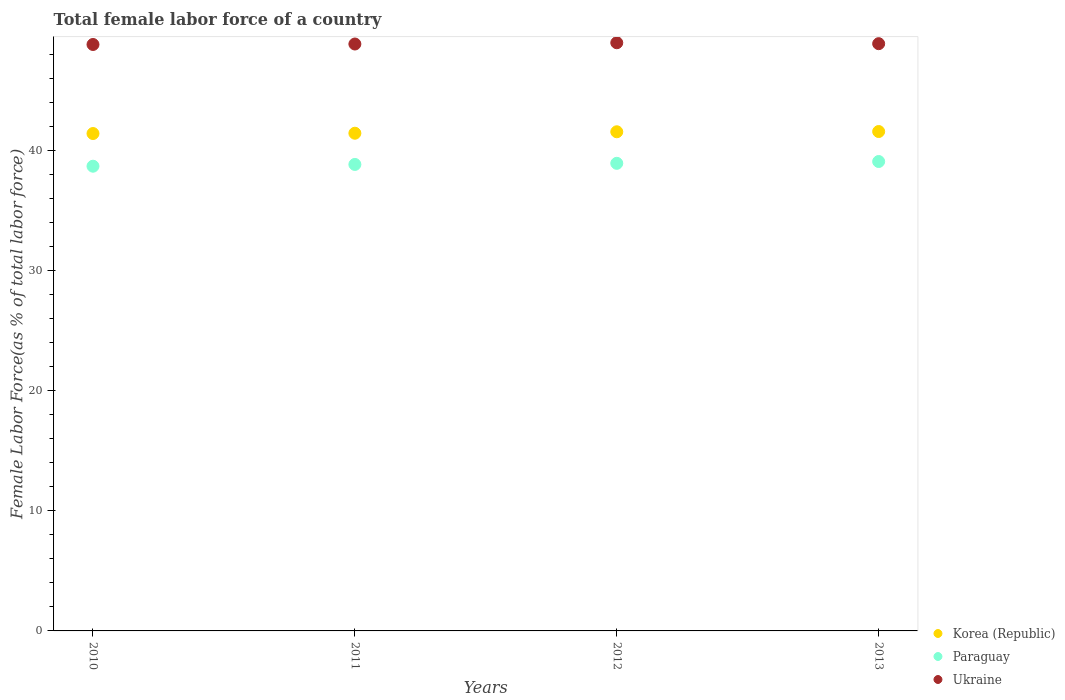What is the percentage of female labor force in Korea (Republic) in 2010?
Your response must be concise. 41.43. Across all years, what is the maximum percentage of female labor force in Paraguay?
Give a very brief answer. 39.1. Across all years, what is the minimum percentage of female labor force in Ukraine?
Ensure brevity in your answer.  48.85. In which year was the percentage of female labor force in Ukraine maximum?
Offer a terse response. 2012. What is the total percentage of female labor force in Paraguay in the graph?
Your answer should be compact. 155.61. What is the difference between the percentage of female labor force in Korea (Republic) in 2011 and that in 2013?
Ensure brevity in your answer.  -0.14. What is the difference between the percentage of female labor force in Ukraine in 2013 and the percentage of female labor force in Paraguay in 2010?
Offer a very short reply. 10.21. What is the average percentage of female labor force in Paraguay per year?
Give a very brief answer. 38.9. In the year 2012, what is the difference between the percentage of female labor force in Ukraine and percentage of female labor force in Korea (Republic)?
Provide a short and direct response. 7.42. What is the ratio of the percentage of female labor force in Ukraine in 2010 to that in 2013?
Offer a terse response. 1. Is the difference between the percentage of female labor force in Ukraine in 2011 and 2012 greater than the difference between the percentage of female labor force in Korea (Republic) in 2011 and 2012?
Provide a short and direct response. Yes. What is the difference between the highest and the second highest percentage of female labor force in Korea (Republic)?
Provide a short and direct response. 0.02. What is the difference between the highest and the lowest percentage of female labor force in Korea (Republic)?
Make the answer very short. 0.17. In how many years, is the percentage of female labor force in Paraguay greater than the average percentage of female labor force in Paraguay taken over all years?
Offer a very short reply. 2. Is the sum of the percentage of female labor force in Ukraine in 2012 and 2013 greater than the maximum percentage of female labor force in Korea (Republic) across all years?
Give a very brief answer. Yes. Does the percentage of female labor force in Paraguay monotonically increase over the years?
Offer a very short reply. Yes. How many dotlines are there?
Give a very brief answer. 3. Does the graph contain grids?
Give a very brief answer. No. How many legend labels are there?
Offer a very short reply. 3. How are the legend labels stacked?
Your response must be concise. Vertical. What is the title of the graph?
Give a very brief answer. Total female labor force of a country. What is the label or title of the X-axis?
Your response must be concise. Years. What is the label or title of the Y-axis?
Give a very brief answer. Female Labor Force(as % of total labor force). What is the Female Labor Force(as % of total labor force) in Korea (Republic) in 2010?
Your answer should be very brief. 41.43. What is the Female Labor Force(as % of total labor force) of Paraguay in 2010?
Give a very brief answer. 38.71. What is the Female Labor Force(as % of total labor force) in Ukraine in 2010?
Your answer should be very brief. 48.85. What is the Female Labor Force(as % of total labor force) in Korea (Republic) in 2011?
Your answer should be very brief. 41.45. What is the Female Labor Force(as % of total labor force) in Paraguay in 2011?
Offer a very short reply. 38.85. What is the Female Labor Force(as % of total labor force) in Ukraine in 2011?
Ensure brevity in your answer.  48.88. What is the Female Labor Force(as % of total labor force) in Korea (Republic) in 2012?
Offer a terse response. 41.57. What is the Female Labor Force(as % of total labor force) of Paraguay in 2012?
Offer a terse response. 38.95. What is the Female Labor Force(as % of total labor force) in Ukraine in 2012?
Provide a short and direct response. 48.99. What is the Female Labor Force(as % of total labor force) of Korea (Republic) in 2013?
Keep it short and to the point. 41.6. What is the Female Labor Force(as % of total labor force) of Paraguay in 2013?
Your answer should be compact. 39.1. What is the Female Labor Force(as % of total labor force) of Ukraine in 2013?
Offer a terse response. 48.91. Across all years, what is the maximum Female Labor Force(as % of total labor force) of Korea (Republic)?
Offer a very short reply. 41.6. Across all years, what is the maximum Female Labor Force(as % of total labor force) of Paraguay?
Your answer should be very brief. 39.1. Across all years, what is the maximum Female Labor Force(as % of total labor force) of Ukraine?
Your response must be concise. 48.99. Across all years, what is the minimum Female Labor Force(as % of total labor force) of Korea (Republic)?
Provide a short and direct response. 41.43. Across all years, what is the minimum Female Labor Force(as % of total labor force) of Paraguay?
Your answer should be very brief. 38.71. Across all years, what is the minimum Female Labor Force(as % of total labor force) of Ukraine?
Offer a terse response. 48.85. What is the total Female Labor Force(as % of total labor force) of Korea (Republic) in the graph?
Offer a very short reply. 166.05. What is the total Female Labor Force(as % of total labor force) of Paraguay in the graph?
Offer a terse response. 155.61. What is the total Female Labor Force(as % of total labor force) of Ukraine in the graph?
Your response must be concise. 195.63. What is the difference between the Female Labor Force(as % of total labor force) of Korea (Republic) in 2010 and that in 2011?
Make the answer very short. -0.02. What is the difference between the Female Labor Force(as % of total labor force) in Paraguay in 2010 and that in 2011?
Provide a succinct answer. -0.15. What is the difference between the Female Labor Force(as % of total labor force) of Ukraine in 2010 and that in 2011?
Offer a terse response. -0.04. What is the difference between the Female Labor Force(as % of total labor force) in Korea (Republic) in 2010 and that in 2012?
Provide a short and direct response. -0.15. What is the difference between the Female Labor Force(as % of total labor force) in Paraguay in 2010 and that in 2012?
Make the answer very short. -0.24. What is the difference between the Female Labor Force(as % of total labor force) of Ukraine in 2010 and that in 2012?
Provide a short and direct response. -0.14. What is the difference between the Female Labor Force(as % of total labor force) of Korea (Republic) in 2010 and that in 2013?
Offer a terse response. -0.17. What is the difference between the Female Labor Force(as % of total labor force) of Paraguay in 2010 and that in 2013?
Your answer should be very brief. -0.39. What is the difference between the Female Labor Force(as % of total labor force) of Ukraine in 2010 and that in 2013?
Provide a succinct answer. -0.07. What is the difference between the Female Labor Force(as % of total labor force) in Korea (Republic) in 2011 and that in 2012?
Provide a succinct answer. -0.12. What is the difference between the Female Labor Force(as % of total labor force) of Paraguay in 2011 and that in 2012?
Offer a terse response. -0.09. What is the difference between the Female Labor Force(as % of total labor force) of Ukraine in 2011 and that in 2012?
Provide a short and direct response. -0.11. What is the difference between the Female Labor Force(as % of total labor force) of Korea (Republic) in 2011 and that in 2013?
Provide a succinct answer. -0.14. What is the difference between the Female Labor Force(as % of total labor force) of Paraguay in 2011 and that in 2013?
Ensure brevity in your answer.  -0.24. What is the difference between the Female Labor Force(as % of total labor force) of Ukraine in 2011 and that in 2013?
Offer a very short reply. -0.03. What is the difference between the Female Labor Force(as % of total labor force) in Korea (Republic) in 2012 and that in 2013?
Ensure brevity in your answer.  -0.02. What is the difference between the Female Labor Force(as % of total labor force) of Paraguay in 2012 and that in 2013?
Provide a short and direct response. -0.15. What is the difference between the Female Labor Force(as % of total labor force) in Ukraine in 2012 and that in 2013?
Give a very brief answer. 0.08. What is the difference between the Female Labor Force(as % of total labor force) of Korea (Republic) in 2010 and the Female Labor Force(as % of total labor force) of Paraguay in 2011?
Provide a succinct answer. 2.57. What is the difference between the Female Labor Force(as % of total labor force) in Korea (Republic) in 2010 and the Female Labor Force(as % of total labor force) in Ukraine in 2011?
Offer a very short reply. -7.46. What is the difference between the Female Labor Force(as % of total labor force) of Paraguay in 2010 and the Female Labor Force(as % of total labor force) of Ukraine in 2011?
Provide a succinct answer. -10.18. What is the difference between the Female Labor Force(as % of total labor force) in Korea (Republic) in 2010 and the Female Labor Force(as % of total labor force) in Paraguay in 2012?
Offer a terse response. 2.48. What is the difference between the Female Labor Force(as % of total labor force) in Korea (Republic) in 2010 and the Female Labor Force(as % of total labor force) in Ukraine in 2012?
Keep it short and to the point. -7.56. What is the difference between the Female Labor Force(as % of total labor force) of Paraguay in 2010 and the Female Labor Force(as % of total labor force) of Ukraine in 2012?
Offer a terse response. -10.28. What is the difference between the Female Labor Force(as % of total labor force) of Korea (Republic) in 2010 and the Female Labor Force(as % of total labor force) of Paraguay in 2013?
Your response must be concise. 2.33. What is the difference between the Female Labor Force(as % of total labor force) of Korea (Republic) in 2010 and the Female Labor Force(as % of total labor force) of Ukraine in 2013?
Offer a very short reply. -7.48. What is the difference between the Female Labor Force(as % of total labor force) of Paraguay in 2010 and the Female Labor Force(as % of total labor force) of Ukraine in 2013?
Your answer should be compact. -10.21. What is the difference between the Female Labor Force(as % of total labor force) in Korea (Republic) in 2011 and the Female Labor Force(as % of total labor force) in Paraguay in 2012?
Give a very brief answer. 2.51. What is the difference between the Female Labor Force(as % of total labor force) of Korea (Republic) in 2011 and the Female Labor Force(as % of total labor force) of Ukraine in 2012?
Offer a terse response. -7.54. What is the difference between the Female Labor Force(as % of total labor force) of Paraguay in 2011 and the Female Labor Force(as % of total labor force) of Ukraine in 2012?
Make the answer very short. -10.14. What is the difference between the Female Labor Force(as % of total labor force) in Korea (Republic) in 2011 and the Female Labor Force(as % of total labor force) in Paraguay in 2013?
Give a very brief answer. 2.36. What is the difference between the Female Labor Force(as % of total labor force) of Korea (Republic) in 2011 and the Female Labor Force(as % of total labor force) of Ukraine in 2013?
Give a very brief answer. -7.46. What is the difference between the Female Labor Force(as % of total labor force) of Paraguay in 2011 and the Female Labor Force(as % of total labor force) of Ukraine in 2013?
Your response must be concise. -10.06. What is the difference between the Female Labor Force(as % of total labor force) in Korea (Republic) in 2012 and the Female Labor Force(as % of total labor force) in Paraguay in 2013?
Provide a short and direct response. 2.48. What is the difference between the Female Labor Force(as % of total labor force) in Korea (Republic) in 2012 and the Female Labor Force(as % of total labor force) in Ukraine in 2013?
Your answer should be very brief. -7.34. What is the difference between the Female Labor Force(as % of total labor force) of Paraguay in 2012 and the Female Labor Force(as % of total labor force) of Ukraine in 2013?
Your answer should be compact. -9.97. What is the average Female Labor Force(as % of total labor force) of Korea (Republic) per year?
Your answer should be compact. 41.51. What is the average Female Labor Force(as % of total labor force) of Paraguay per year?
Give a very brief answer. 38.9. What is the average Female Labor Force(as % of total labor force) in Ukraine per year?
Provide a succinct answer. 48.91. In the year 2010, what is the difference between the Female Labor Force(as % of total labor force) of Korea (Republic) and Female Labor Force(as % of total labor force) of Paraguay?
Keep it short and to the point. 2.72. In the year 2010, what is the difference between the Female Labor Force(as % of total labor force) of Korea (Republic) and Female Labor Force(as % of total labor force) of Ukraine?
Make the answer very short. -7.42. In the year 2010, what is the difference between the Female Labor Force(as % of total labor force) in Paraguay and Female Labor Force(as % of total labor force) in Ukraine?
Offer a terse response. -10.14. In the year 2011, what is the difference between the Female Labor Force(as % of total labor force) in Korea (Republic) and Female Labor Force(as % of total labor force) in Paraguay?
Make the answer very short. 2.6. In the year 2011, what is the difference between the Female Labor Force(as % of total labor force) of Korea (Republic) and Female Labor Force(as % of total labor force) of Ukraine?
Ensure brevity in your answer.  -7.43. In the year 2011, what is the difference between the Female Labor Force(as % of total labor force) in Paraguay and Female Labor Force(as % of total labor force) in Ukraine?
Your answer should be compact. -10.03. In the year 2012, what is the difference between the Female Labor Force(as % of total labor force) of Korea (Republic) and Female Labor Force(as % of total labor force) of Paraguay?
Make the answer very short. 2.63. In the year 2012, what is the difference between the Female Labor Force(as % of total labor force) in Korea (Republic) and Female Labor Force(as % of total labor force) in Ukraine?
Make the answer very short. -7.42. In the year 2012, what is the difference between the Female Labor Force(as % of total labor force) in Paraguay and Female Labor Force(as % of total labor force) in Ukraine?
Your answer should be very brief. -10.04. In the year 2013, what is the difference between the Female Labor Force(as % of total labor force) of Korea (Republic) and Female Labor Force(as % of total labor force) of Paraguay?
Offer a very short reply. 2.5. In the year 2013, what is the difference between the Female Labor Force(as % of total labor force) in Korea (Republic) and Female Labor Force(as % of total labor force) in Ukraine?
Offer a very short reply. -7.32. In the year 2013, what is the difference between the Female Labor Force(as % of total labor force) in Paraguay and Female Labor Force(as % of total labor force) in Ukraine?
Offer a very short reply. -9.81. What is the ratio of the Female Labor Force(as % of total labor force) of Korea (Republic) in 2010 to that in 2013?
Your answer should be compact. 1. What is the ratio of the Female Labor Force(as % of total labor force) in Paraguay in 2010 to that in 2013?
Your answer should be compact. 0.99. What is the ratio of the Female Labor Force(as % of total labor force) of Ukraine in 2010 to that in 2013?
Provide a succinct answer. 1. What is the ratio of the Female Labor Force(as % of total labor force) of Korea (Republic) in 2011 to that in 2012?
Your answer should be compact. 1. What is the ratio of the Female Labor Force(as % of total labor force) in Paraguay in 2011 to that in 2012?
Provide a succinct answer. 1. What is the ratio of the Female Labor Force(as % of total labor force) in Paraguay in 2011 to that in 2013?
Offer a very short reply. 0.99. What is the ratio of the Female Labor Force(as % of total labor force) of Ukraine in 2011 to that in 2013?
Give a very brief answer. 1. What is the ratio of the Female Labor Force(as % of total labor force) in Korea (Republic) in 2012 to that in 2013?
Offer a terse response. 1. What is the difference between the highest and the second highest Female Labor Force(as % of total labor force) in Korea (Republic)?
Offer a terse response. 0.02. What is the difference between the highest and the second highest Female Labor Force(as % of total labor force) in Paraguay?
Ensure brevity in your answer.  0.15. What is the difference between the highest and the second highest Female Labor Force(as % of total labor force) in Ukraine?
Provide a succinct answer. 0.08. What is the difference between the highest and the lowest Female Labor Force(as % of total labor force) in Korea (Republic)?
Your answer should be very brief. 0.17. What is the difference between the highest and the lowest Female Labor Force(as % of total labor force) in Paraguay?
Your response must be concise. 0.39. What is the difference between the highest and the lowest Female Labor Force(as % of total labor force) of Ukraine?
Keep it short and to the point. 0.14. 